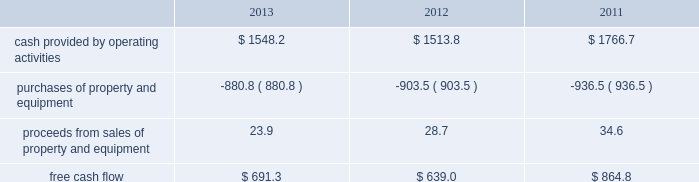Constitutes an event of default under our other debt instruments , including our senior notes , and , therefore , our senior notes would also be subject to acceleration of maturity .
If such acceleration were to occur , we would not have sufficient liquidity available to repay the indebtedness .
We would likely have to seek an amendment under our credit facilities for relief from the financial covenants or repay the debt with proceeds from the issuance of new debt or equity , or asset sales , if necessary .
We may be unable to amend our credit facilities or raise sufficient capital to repay such obligations in the event the maturities are accelerated .
Financial assurance we must provide financial assurance to governmental agencies and a variety of other entities under applicable environmental regulations relating to our landfill operations for capping , closure and post-closure costs , and related to our performance under certain collection , landfill and transfer station contracts .
We satisfy these financial assurance requirements by providing surety bonds , letters of credit , or insurance policies ( the financial assurance instruments ) , or trust deposits , which are included in restricted cash and marketable securities and other assets in our consolidated balance sheets .
The amount of the financial assurance requirements for capping , closure and post-closure costs is determined by applicable state environmental regulations .
The financial assurance requirements for capping , closure and post-closure costs may be associated with a portion of the landfill or the entire landfill .
Generally , states require a third-party engineering specialist to determine the estimated capping , closure and post-closure costs that are used to determine the required amount of financial assurance for a landfill .
The amount of financial assurance required can , and generally will , differ from the obligation determined and recorded under u.s .
Gaap .
The amount of the financial assurance requirements related to contract performance varies by contract .
Additionally , we must provide financial assurance for our insurance program and collateral for certain performance obligations .
We do not expect a material increase in financial assurance requirements during 2014 , although the mix of financial assurance instruments may change .
These financial instruments are issued in the normal course of business and are not considered indebtedness .
Because we currently have no liability for the financial assurance instruments , they are not reflected in our consolidated balance sheets ; however , we record capping , closure and post-closure liabilities and self-insurance liabilities as they are incurred .
The underlying obligations of the financial assurance instruments , in excess of those already reflected in our consolidated balance sheets , would be recorded if it is probable that we would be unable to fulfill our related obligations .
We do not expect this to occur .
Off-balance sheet arrangements we have no off-balance sheet debt or similar obligations , other than financial assurance instruments and operating leases , that are not classified as debt .
We do not guarantee any third-party debt .
Free cash flow we define free cash flow , which is not a measure determined in accordance with u.s .
Gaap , as cash provided by operating activities less purchases of property and equipment , plus proceeds from sales of property and equipment as presented in our consolidated statements of cash flows .
Our free cash flow for the years ended december 31 , 2013 , 2012 and 2011 is calculated as follows ( in millions of dollars ) : .

What was the percent of the growth in the free cash flow from 2012 to 2013? 
Rationale: the growth in the free cash flow from 2012 to 2013 was 8.2%
Computations: ((691.3 - 639.0) / 639.0)
Answer: 0.08185. 